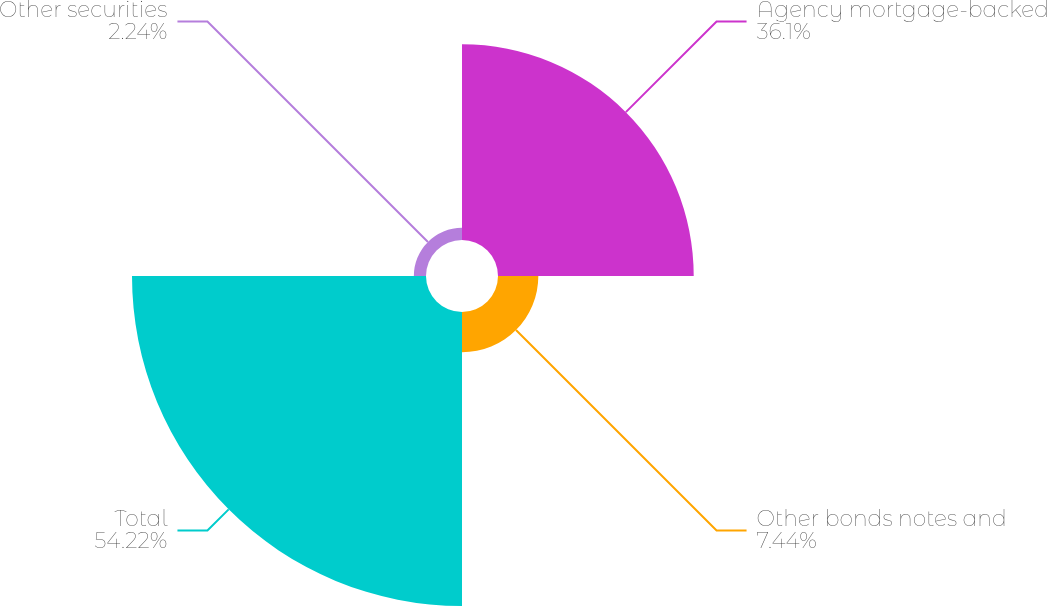Convert chart. <chart><loc_0><loc_0><loc_500><loc_500><pie_chart><fcel>Agency mortgage-backed<fcel>Other bonds notes and<fcel>Total<fcel>Other securities<nl><fcel>36.1%<fcel>7.44%<fcel>54.23%<fcel>2.24%<nl></chart> 